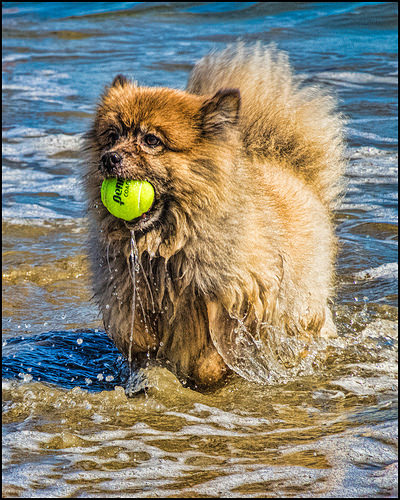<image>
Is the ball in the dog? Yes. The ball is contained within or inside the dog, showing a containment relationship. Where is the fur in relation to the ball? Is it next to the ball? Yes. The fur is positioned adjacent to the ball, located nearby in the same general area. 